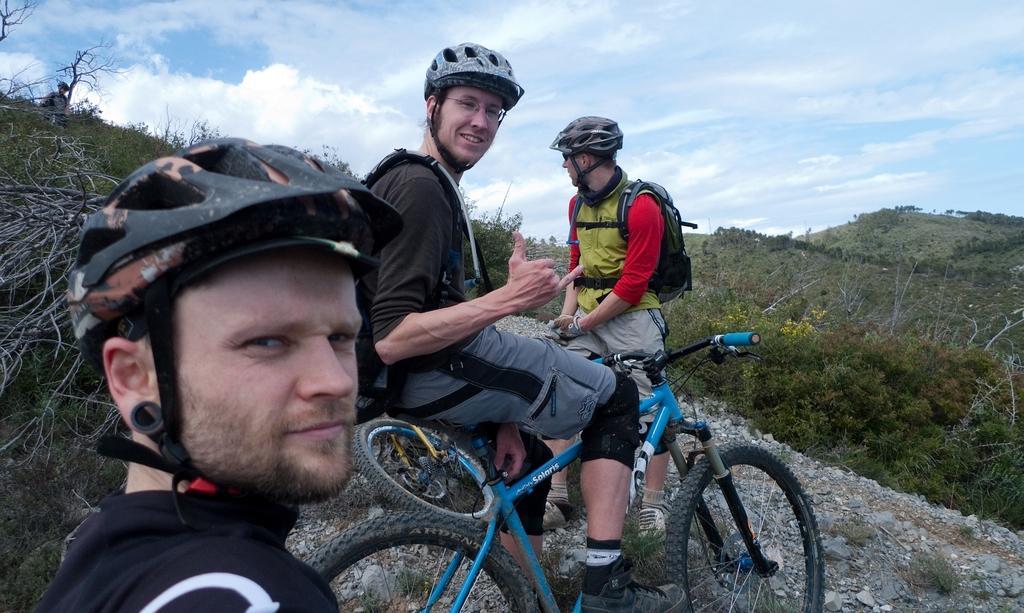In one or two sentences, can you explain what this image depicts? In this image we can see there are three persons sitting on the bicycle. And there are mountains, trees, flowers and the sky. 